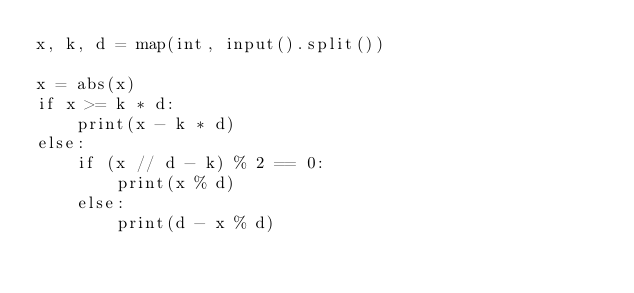Convert code to text. <code><loc_0><loc_0><loc_500><loc_500><_Python_>x, k, d = map(int, input().split())

x = abs(x)
if x >= k * d:
    print(x - k * d)
else:
    if (x // d - k) % 2 == 0:
        print(x % d)
    else:
        print(d - x % d)
</code> 